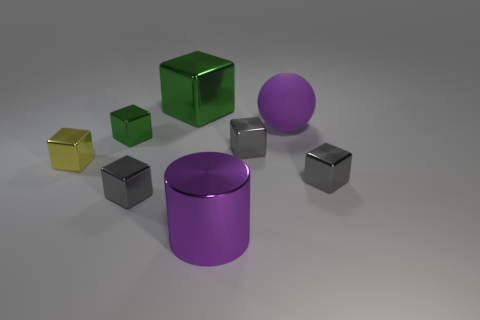What size is the metallic object that is the same color as the big rubber object?
Ensure brevity in your answer.  Large. Do the large rubber thing that is on the right side of the big cylinder and the large cylinder have the same color?
Provide a succinct answer. Yes. What shape is the large metallic thing that is the same color as the big rubber sphere?
Your response must be concise. Cylinder. Is there a shiny thing of the same color as the large metallic block?
Give a very brief answer. Yes. Is there anything else that has the same shape as the purple rubber thing?
Provide a succinct answer. No. What number of things are small gray metallic things or small things?
Provide a short and direct response. 5. Do the purple sphere and the purple thing that is in front of the yellow metallic block have the same size?
Offer a very short reply. Yes. The big thing to the right of the large purple object in front of the gray metallic block that is to the right of the purple matte thing is what color?
Ensure brevity in your answer.  Purple. The big block is what color?
Provide a succinct answer. Green. Are there more matte balls that are behind the big metal block than big balls to the left of the small green metal object?
Keep it short and to the point. No. 